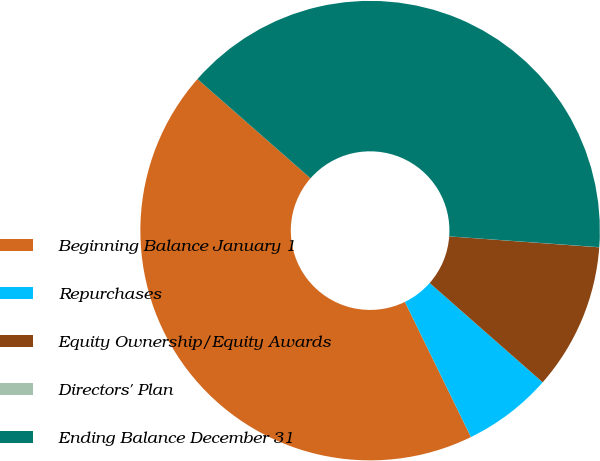Convert chart. <chart><loc_0><loc_0><loc_500><loc_500><pie_chart><fcel>Beginning Balance January 1<fcel>Repurchases<fcel>Equity Ownership/Equity Awards<fcel>Directors' Plan<fcel>Ending Balance December 31<nl><fcel>43.7%<fcel>6.29%<fcel>10.32%<fcel>0.01%<fcel>39.68%<nl></chart> 